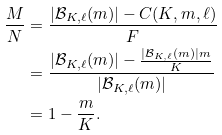<formula> <loc_0><loc_0><loc_500><loc_500>\frac { M } { N } & = \frac { | \mathcal { B } _ { K , \ell } ( m ) | - C ( K , m , \ell ) } { F } \\ & = \frac { | \mathcal { B } _ { K , \ell } ( m ) | - \frac { | \mathcal { B } _ { K , \ell } ( m ) | m } { K } } { | \mathcal { B } _ { K , \ell } ( m ) | } \\ & = 1 - \frac { m } { K } .</formula> 